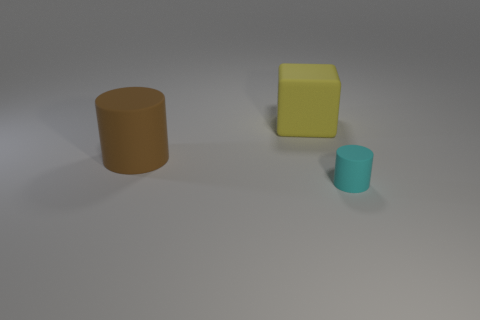Add 2 large yellow rubber cubes. How many objects exist? 5 Subtract all cylinders. How many objects are left? 1 Subtract all metallic cubes. Subtract all brown cylinders. How many objects are left? 2 Add 2 brown objects. How many brown objects are left? 3 Add 1 gray metallic cylinders. How many gray metallic cylinders exist? 1 Subtract 0 red cubes. How many objects are left? 3 